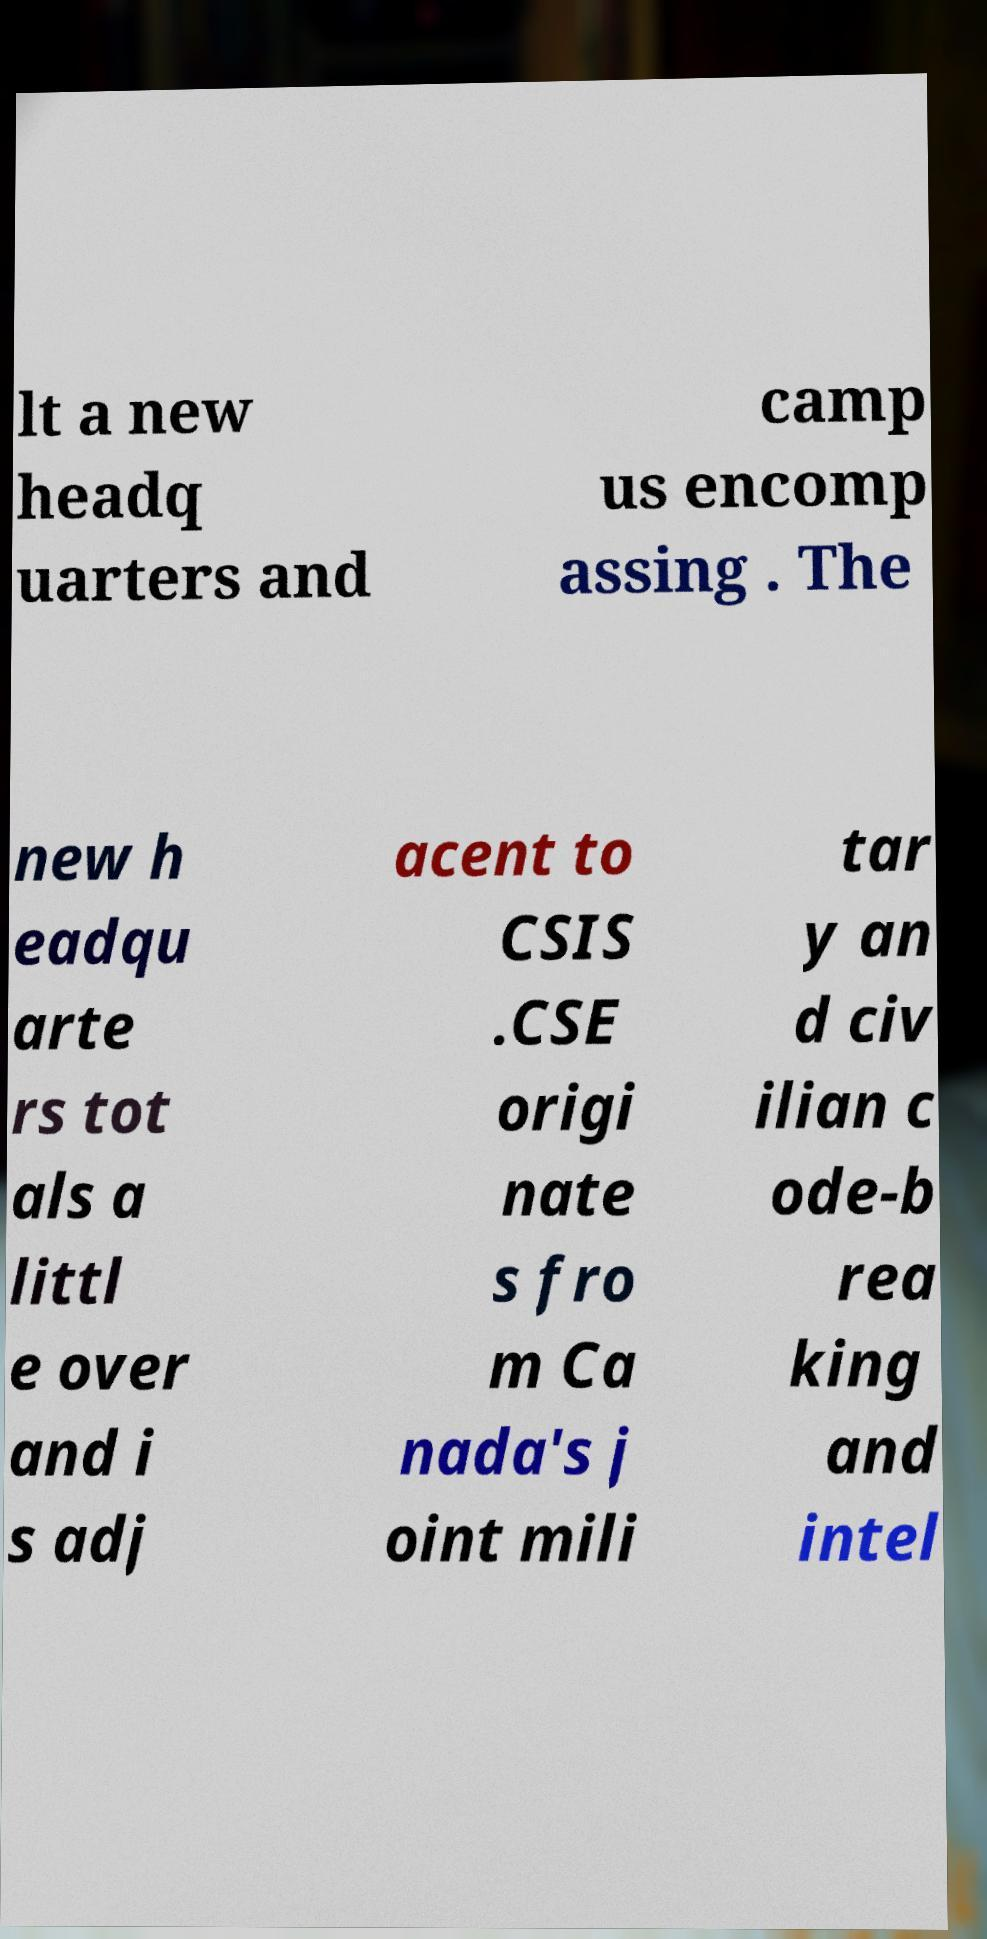Can you accurately transcribe the text from the provided image for me? lt a new headq uarters and camp us encomp assing . The new h eadqu arte rs tot als a littl e over and i s adj acent to CSIS .CSE origi nate s fro m Ca nada's j oint mili tar y an d civ ilian c ode-b rea king and intel 